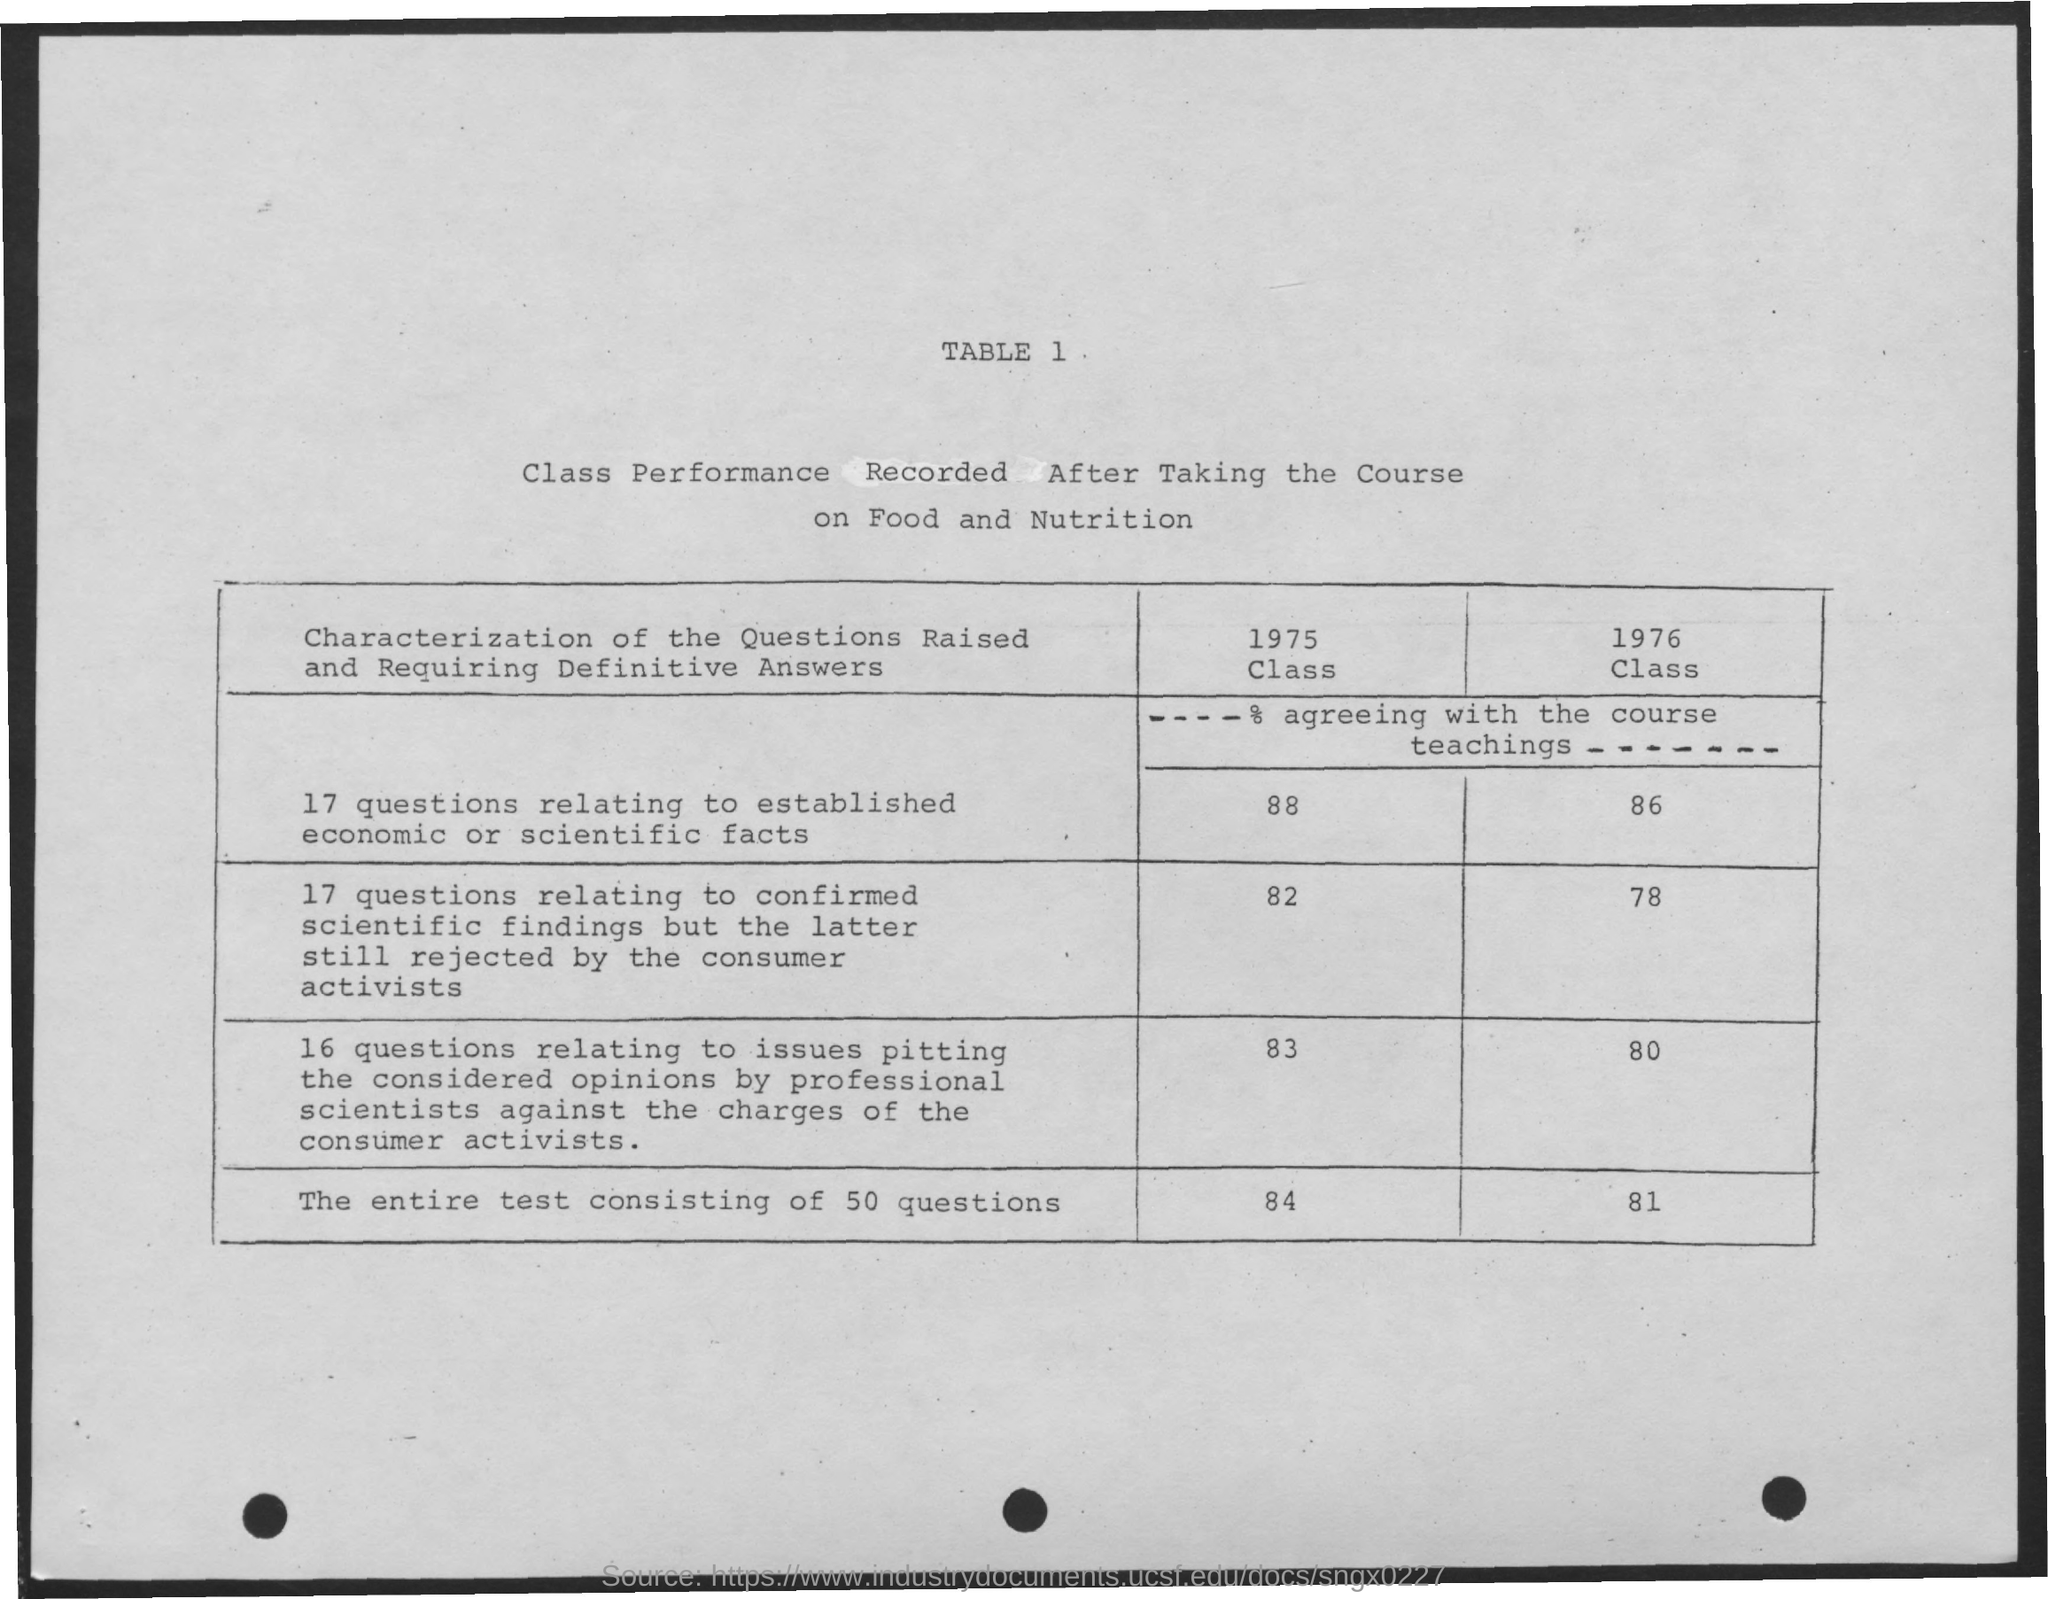What is the heading of the document?
Provide a succinct answer. TABLE 1. What is the table about?
Offer a very short reply. Class Performance Recorded After Taking the Course on Food and Nutrition. 